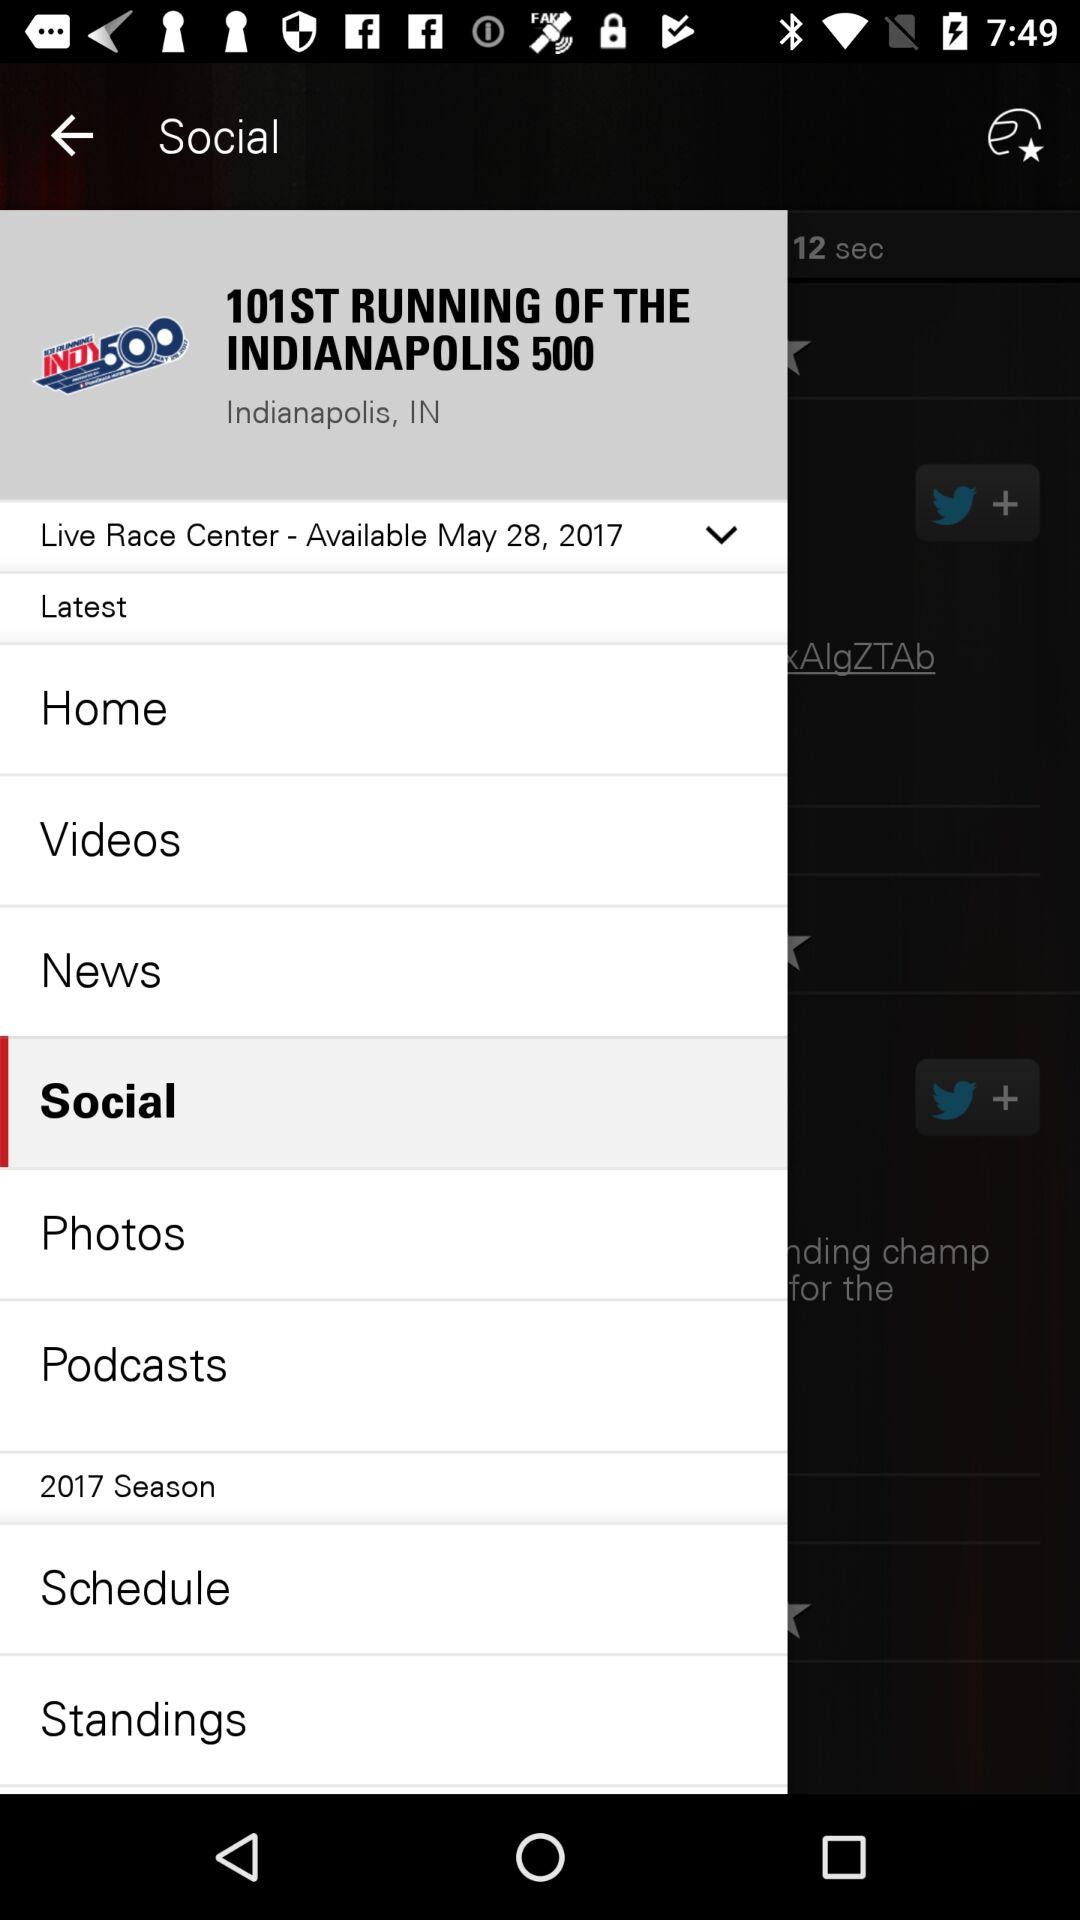When is the "101ST RUNNING OF THE INDIANAPOLIS 500" event? The event "101ST RUNNING OF THE INDIANAPOLIS 500" is on May 28, 2017. 